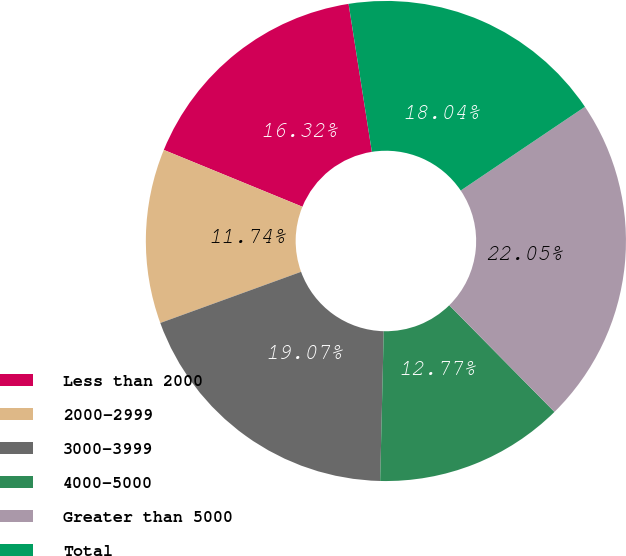<chart> <loc_0><loc_0><loc_500><loc_500><pie_chart><fcel>Less than 2000<fcel>2000-2999<fcel>3000-3999<fcel>4000-5000<fcel>Greater than 5000<fcel>Total<nl><fcel>16.32%<fcel>11.74%<fcel>19.07%<fcel>12.77%<fcel>22.05%<fcel>18.04%<nl></chart> 